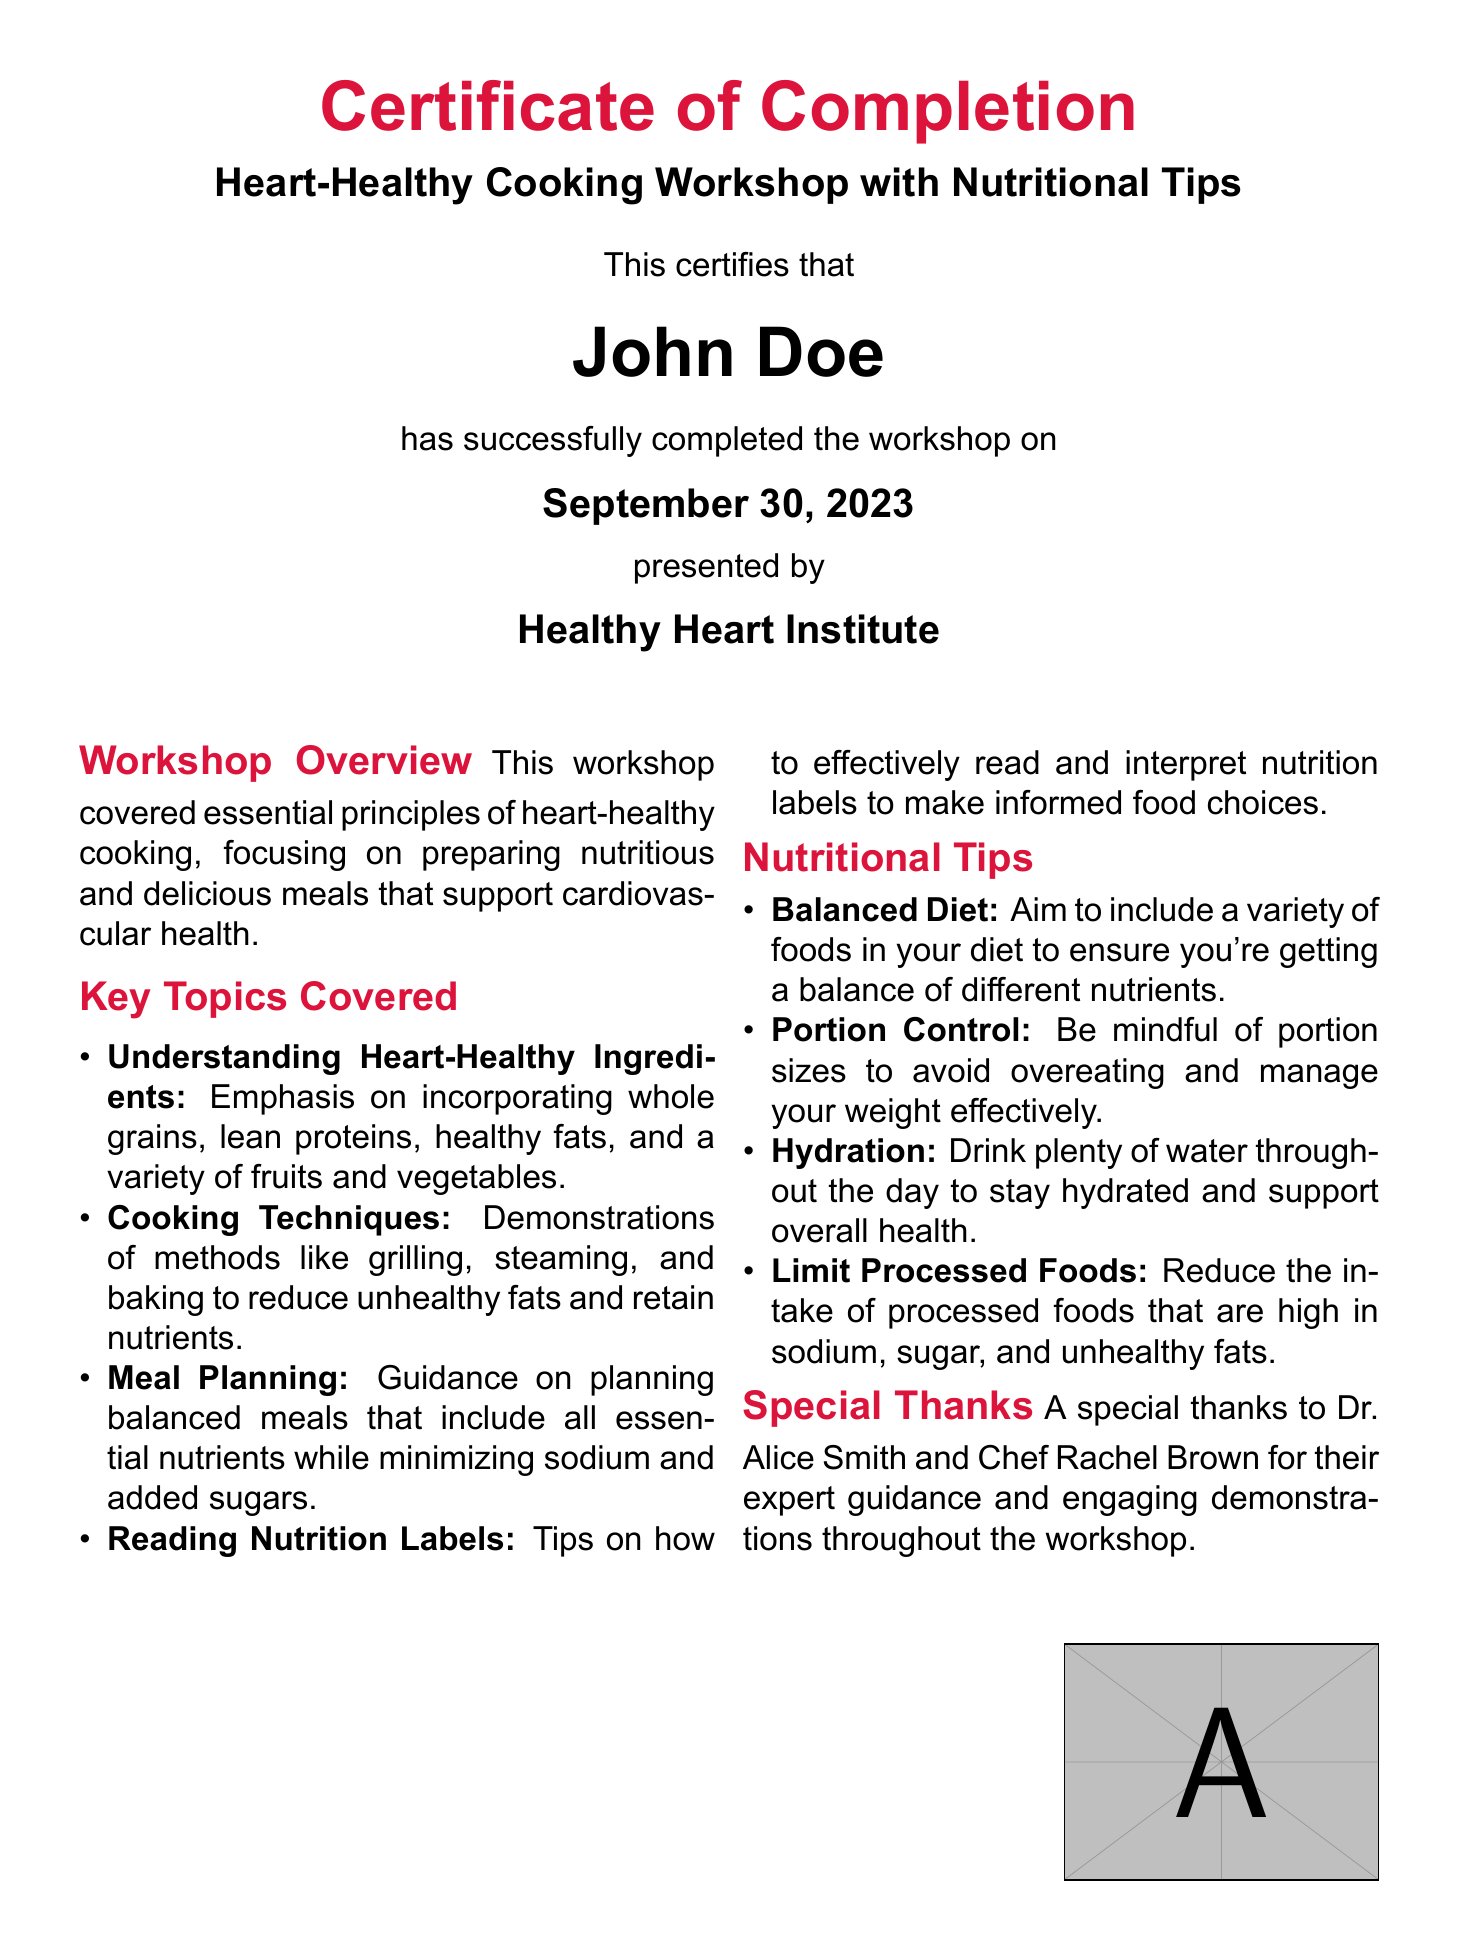what is the title of the workshop? The title is stated prominently on the certificate as part of the header.
Answer: Heart-Healthy Cooking Workshop with Nutritional Tips who is the recipient of the certificate? The recipient's name is highlighted in a larger font, denoting the individual who completed the workshop.
Answer: John Doe what date did the workshop take place? The date is specified in the certificate indicating when the completion was achieved.
Answer: September 30, 2023 who presented the workshop? The presenting organization is mentioned at the bottom of the certificate, reflecting the authority behind the event.
Answer: Healthy Heart Institute name one cooking technique demonstrated in the workshop. The workshop description lists various cooking methods, which indicates the focus on heart-healthy practices.
Answer: Grilling what is one nutritional tip given in the workshop? The nutritional tips section includes several pieces of advice regarding healthy eating practices.
Answer: Balanced Diet who provided expert guidance during the workshop? The special thanks section names individuals who contributed to the workshop, showing appreciation for their roles.
Answer: Dr. Alice Smith what is the role of Dr. Robert Taylor as mentioned in the document? The certificate includes a signature section indicating the position of the individual who authorized the certificate.
Answer: Director of Nutritional Programs 